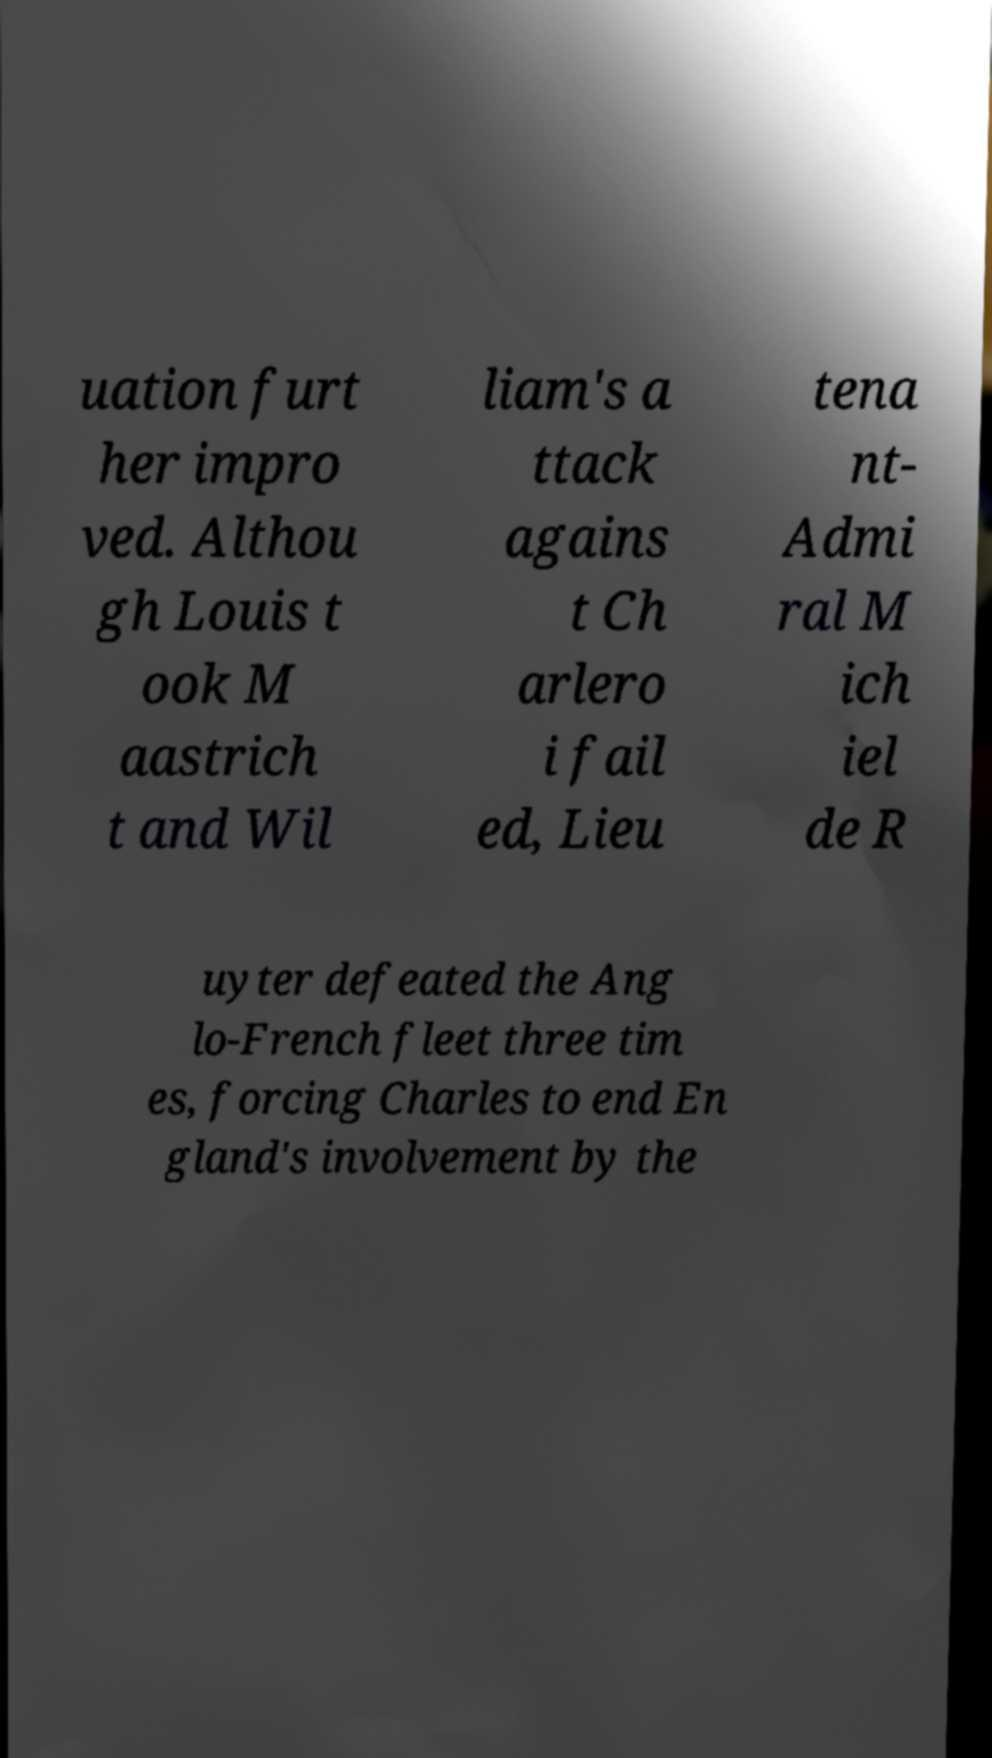I need the written content from this picture converted into text. Can you do that? uation furt her impro ved. Althou gh Louis t ook M aastrich t and Wil liam's a ttack agains t Ch arlero i fail ed, Lieu tena nt- Admi ral M ich iel de R uyter defeated the Ang lo-French fleet three tim es, forcing Charles to end En gland's involvement by the 